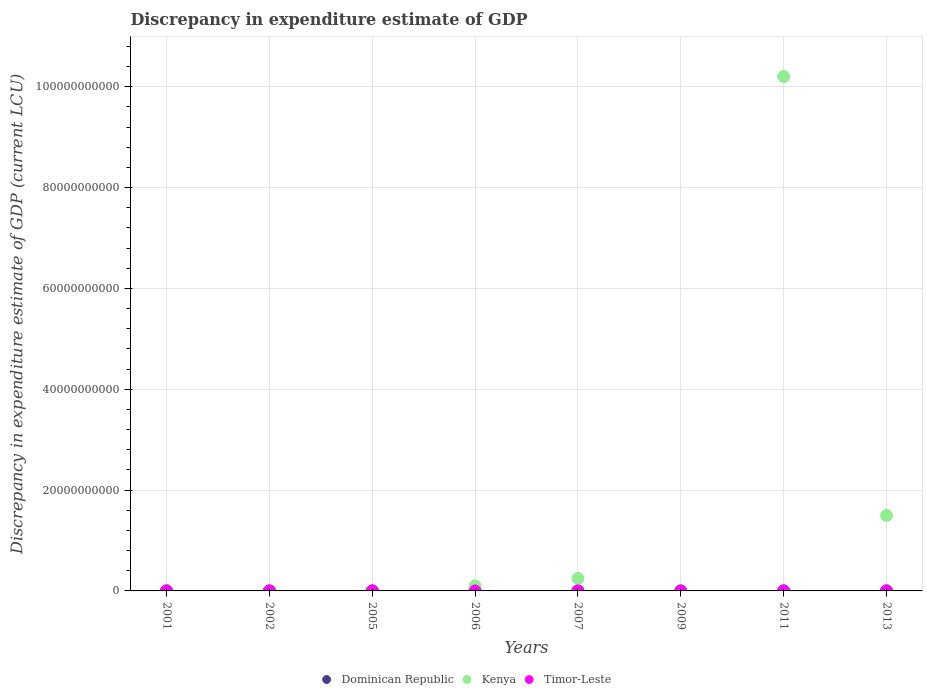How many different coloured dotlines are there?
Provide a short and direct response. 3. Is the number of dotlines equal to the number of legend labels?
Your response must be concise. No. Across all years, what is the maximum discrepancy in expenditure estimate of GDP in Kenya?
Offer a very short reply. 1.02e+11. Across all years, what is the minimum discrepancy in expenditure estimate of GDP in Timor-Leste?
Provide a succinct answer. 0. In which year was the discrepancy in expenditure estimate of GDP in Dominican Republic maximum?
Your answer should be compact. 2001. What is the total discrepancy in expenditure estimate of GDP in Timor-Leste in the graph?
Provide a succinct answer. 2.50e+06. What is the difference between the discrepancy in expenditure estimate of GDP in Dominican Republic in 2005 and that in 2007?
Provide a succinct answer. -100.12. What is the average discrepancy in expenditure estimate of GDP in Dominican Republic per year?
Your answer should be compact. 1.25e+04. In the year 2006, what is the difference between the discrepancy in expenditure estimate of GDP in Kenya and discrepancy in expenditure estimate of GDP in Dominican Republic?
Your answer should be very brief. 1.01e+09. What is the ratio of the discrepancy in expenditure estimate of GDP in Kenya in 2007 to that in 2013?
Give a very brief answer. 0.17. What is the difference between the highest and the second highest discrepancy in expenditure estimate of GDP in Dominican Republic?
Your answer should be compact. 9.99e+04. What is the difference between the highest and the lowest discrepancy in expenditure estimate of GDP in Kenya?
Your answer should be very brief. 1.02e+11. In how many years, is the discrepancy in expenditure estimate of GDP in Dominican Republic greater than the average discrepancy in expenditure estimate of GDP in Dominican Republic taken over all years?
Your answer should be compact. 1. Is the sum of the discrepancy in expenditure estimate of GDP in Dominican Republic in 2001 and 2005 greater than the maximum discrepancy in expenditure estimate of GDP in Timor-Leste across all years?
Keep it short and to the point. No. Is it the case that in every year, the sum of the discrepancy in expenditure estimate of GDP in Dominican Republic and discrepancy in expenditure estimate of GDP in Kenya  is greater than the discrepancy in expenditure estimate of GDP in Timor-Leste?
Ensure brevity in your answer.  No. Is the discrepancy in expenditure estimate of GDP in Kenya strictly less than the discrepancy in expenditure estimate of GDP in Timor-Leste over the years?
Make the answer very short. No. Are the values on the major ticks of Y-axis written in scientific E-notation?
Keep it short and to the point. No. Does the graph contain any zero values?
Make the answer very short. Yes. Does the graph contain grids?
Provide a short and direct response. Yes. How many legend labels are there?
Your response must be concise. 3. How are the legend labels stacked?
Your response must be concise. Horizontal. What is the title of the graph?
Provide a short and direct response. Discrepancy in expenditure estimate of GDP. Does "Slovak Republic" appear as one of the legend labels in the graph?
Offer a terse response. No. What is the label or title of the X-axis?
Your answer should be very brief. Years. What is the label or title of the Y-axis?
Offer a very short reply. Discrepancy in expenditure estimate of GDP (current LCU). What is the Discrepancy in expenditure estimate of GDP (current LCU) in Dominican Republic in 2001?
Make the answer very short. 1.00e+05. What is the Discrepancy in expenditure estimate of GDP (current LCU) of Timor-Leste in 2001?
Keep it short and to the point. 1.00e+06. What is the Discrepancy in expenditure estimate of GDP (current LCU) in Dominican Republic in 2002?
Ensure brevity in your answer.  0. What is the Discrepancy in expenditure estimate of GDP (current LCU) of Kenya in 2002?
Your answer should be very brief. 0. What is the Discrepancy in expenditure estimate of GDP (current LCU) of Timor-Leste in 2002?
Your answer should be very brief. 0. What is the Discrepancy in expenditure estimate of GDP (current LCU) in Dominican Republic in 2005?
Keep it short and to the point. 8e-6. What is the Discrepancy in expenditure estimate of GDP (current LCU) in Dominican Republic in 2006?
Ensure brevity in your answer.  0. What is the Discrepancy in expenditure estimate of GDP (current LCU) in Kenya in 2006?
Make the answer very short. 1.01e+09. What is the Discrepancy in expenditure estimate of GDP (current LCU) of Timor-Leste in 2006?
Your response must be concise. 1.34e-7. What is the Discrepancy in expenditure estimate of GDP (current LCU) of Dominican Republic in 2007?
Your response must be concise. 100.12. What is the Discrepancy in expenditure estimate of GDP (current LCU) in Kenya in 2007?
Your answer should be compact. 2.49e+09. What is the Discrepancy in expenditure estimate of GDP (current LCU) of Timor-Leste in 2007?
Provide a short and direct response. 1.00e+06. What is the Discrepancy in expenditure estimate of GDP (current LCU) of Dominican Republic in 2009?
Ensure brevity in your answer.  0. What is the Discrepancy in expenditure estimate of GDP (current LCU) of Dominican Republic in 2011?
Give a very brief answer. 92.59. What is the Discrepancy in expenditure estimate of GDP (current LCU) in Kenya in 2011?
Keep it short and to the point. 1.02e+11. What is the Discrepancy in expenditure estimate of GDP (current LCU) of Kenya in 2013?
Give a very brief answer. 1.50e+1. Across all years, what is the maximum Discrepancy in expenditure estimate of GDP (current LCU) in Dominican Republic?
Offer a terse response. 1.00e+05. Across all years, what is the maximum Discrepancy in expenditure estimate of GDP (current LCU) in Kenya?
Offer a terse response. 1.02e+11. Across all years, what is the maximum Discrepancy in expenditure estimate of GDP (current LCU) in Timor-Leste?
Offer a very short reply. 1.00e+06. What is the total Discrepancy in expenditure estimate of GDP (current LCU) of Dominican Republic in the graph?
Offer a very short reply. 1.00e+05. What is the total Discrepancy in expenditure estimate of GDP (current LCU) of Kenya in the graph?
Keep it short and to the point. 1.20e+11. What is the total Discrepancy in expenditure estimate of GDP (current LCU) of Timor-Leste in the graph?
Your answer should be very brief. 2.50e+06. What is the difference between the Discrepancy in expenditure estimate of GDP (current LCU) of Dominican Republic in 2001 and that in 2005?
Ensure brevity in your answer.  1.00e+05. What is the difference between the Discrepancy in expenditure estimate of GDP (current LCU) of Dominican Republic in 2001 and that in 2006?
Offer a terse response. 1.00e+05. What is the difference between the Discrepancy in expenditure estimate of GDP (current LCU) in Dominican Republic in 2001 and that in 2007?
Ensure brevity in your answer.  9.99e+04. What is the difference between the Discrepancy in expenditure estimate of GDP (current LCU) of Dominican Republic in 2001 and that in 2011?
Offer a terse response. 9.99e+04. What is the difference between the Discrepancy in expenditure estimate of GDP (current LCU) of Dominican Republic in 2005 and that in 2006?
Offer a very short reply. -0. What is the difference between the Discrepancy in expenditure estimate of GDP (current LCU) of Timor-Leste in 2005 and that in 2006?
Give a very brief answer. 5.00e+05. What is the difference between the Discrepancy in expenditure estimate of GDP (current LCU) of Dominican Republic in 2005 and that in 2007?
Your answer should be compact. -100.12. What is the difference between the Discrepancy in expenditure estimate of GDP (current LCU) of Timor-Leste in 2005 and that in 2007?
Your answer should be compact. -5.00e+05. What is the difference between the Discrepancy in expenditure estimate of GDP (current LCU) in Dominican Republic in 2005 and that in 2011?
Your answer should be compact. -92.59. What is the difference between the Discrepancy in expenditure estimate of GDP (current LCU) in Dominican Republic in 2006 and that in 2007?
Ensure brevity in your answer.  -100.12. What is the difference between the Discrepancy in expenditure estimate of GDP (current LCU) of Kenya in 2006 and that in 2007?
Provide a short and direct response. -1.48e+09. What is the difference between the Discrepancy in expenditure estimate of GDP (current LCU) of Dominican Republic in 2006 and that in 2011?
Ensure brevity in your answer.  -92.59. What is the difference between the Discrepancy in expenditure estimate of GDP (current LCU) of Kenya in 2006 and that in 2011?
Ensure brevity in your answer.  -1.01e+11. What is the difference between the Discrepancy in expenditure estimate of GDP (current LCU) in Kenya in 2006 and that in 2013?
Offer a very short reply. -1.40e+1. What is the difference between the Discrepancy in expenditure estimate of GDP (current LCU) in Dominican Republic in 2007 and that in 2011?
Ensure brevity in your answer.  7.53. What is the difference between the Discrepancy in expenditure estimate of GDP (current LCU) in Kenya in 2007 and that in 2011?
Provide a succinct answer. -9.95e+1. What is the difference between the Discrepancy in expenditure estimate of GDP (current LCU) of Kenya in 2007 and that in 2013?
Your answer should be compact. -1.25e+1. What is the difference between the Discrepancy in expenditure estimate of GDP (current LCU) in Kenya in 2011 and that in 2013?
Give a very brief answer. 8.71e+1. What is the difference between the Discrepancy in expenditure estimate of GDP (current LCU) in Dominican Republic in 2001 and the Discrepancy in expenditure estimate of GDP (current LCU) in Timor-Leste in 2005?
Your answer should be very brief. -4.00e+05. What is the difference between the Discrepancy in expenditure estimate of GDP (current LCU) of Dominican Republic in 2001 and the Discrepancy in expenditure estimate of GDP (current LCU) of Kenya in 2006?
Provide a succinct answer. -1.01e+09. What is the difference between the Discrepancy in expenditure estimate of GDP (current LCU) of Dominican Republic in 2001 and the Discrepancy in expenditure estimate of GDP (current LCU) of Kenya in 2007?
Ensure brevity in your answer.  -2.49e+09. What is the difference between the Discrepancy in expenditure estimate of GDP (current LCU) in Dominican Republic in 2001 and the Discrepancy in expenditure estimate of GDP (current LCU) in Timor-Leste in 2007?
Your answer should be very brief. -9.00e+05. What is the difference between the Discrepancy in expenditure estimate of GDP (current LCU) in Dominican Republic in 2001 and the Discrepancy in expenditure estimate of GDP (current LCU) in Kenya in 2011?
Make the answer very short. -1.02e+11. What is the difference between the Discrepancy in expenditure estimate of GDP (current LCU) in Dominican Republic in 2001 and the Discrepancy in expenditure estimate of GDP (current LCU) in Kenya in 2013?
Offer a very short reply. -1.50e+1. What is the difference between the Discrepancy in expenditure estimate of GDP (current LCU) of Dominican Republic in 2005 and the Discrepancy in expenditure estimate of GDP (current LCU) of Kenya in 2006?
Keep it short and to the point. -1.01e+09. What is the difference between the Discrepancy in expenditure estimate of GDP (current LCU) of Dominican Republic in 2005 and the Discrepancy in expenditure estimate of GDP (current LCU) of Kenya in 2007?
Provide a short and direct response. -2.49e+09. What is the difference between the Discrepancy in expenditure estimate of GDP (current LCU) of Dominican Republic in 2005 and the Discrepancy in expenditure estimate of GDP (current LCU) of Kenya in 2011?
Make the answer very short. -1.02e+11. What is the difference between the Discrepancy in expenditure estimate of GDP (current LCU) of Dominican Republic in 2005 and the Discrepancy in expenditure estimate of GDP (current LCU) of Kenya in 2013?
Provide a succinct answer. -1.50e+1. What is the difference between the Discrepancy in expenditure estimate of GDP (current LCU) in Dominican Republic in 2006 and the Discrepancy in expenditure estimate of GDP (current LCU) in Kenya in 2007?
Your response must be concise. -2.49e+09. What is the difference between the Discrepancy in expenditure estimate of GDP (current LCU) of Dominican Republic in 2006 and the Discrepancy in expenditure estimate of GDP (current LCU) of Timor-Leste in 2007?
Your response must be concise. -1.00e+06. What is the difference between the Discrepancy in expenditure estimate of GDP (current LCU) of Kenya in 2006 and the Discrepancy in expenditure estimate of GDP (current LCU) of Timor-Leste in 2007?
Your answer should be very brief. 1.01e+09. What is the difference between the Discrepancy in expenditure estimate of GDP (current LCU) in Dominican Republic in 2006 and the Discrepancy in expenditure estimate of GDP (current LCU) in Kenya in 2011?
Offer a terse response. -1.02e+11. What is the difference between the Discrepancy in expenditure estimate of GDP (current LCU) in Dominican Republic in 2006 and the Discrepancy in expenditure estimate of GDP (current LCU) in Kenya in 2013?
Offer a very short reply. -1.50e+1. What is the difference between the Discrepancy in expenditure estimate of GDP (current LCU) of Dominican Republic in 2007 and the Discrepancy in expenditure estimate of GDP (current LCU) of Kenya in 2011?
Offer a very short reply. -1.02e+11. What is the difference between the Discrepancy in expenditure estimate of GDP (current LCU) in Dominican Republic in 2007 and the Discrepancy in expenditure estimate of GDP (current LCU) in Kenya in 2013?
Your answer should be compact. -1.50e+1. What is the difference between the Discrepancy in expenditure estimate of GDP (current LCU) of Dominican Republic in 2011 and the Discrepancy in expenditure estimate of GDP (current LCU) of Kenya in 2013?
Give a very brief answer. -1.50e+1. What is the average Discrepancy in expenditure estimate of GDP (current LCU) in Dominican Republic per year?
Keep it short and to the point. 1.25e+04. What is the average Discrepancy in expenditure estimate of GDP (current LCU) in Kenya per year?
Keep it short and to the point. 1.51e+1. What is the average Discrepancy in expenditure estimate of GDP (current LCU) of Timor-Leste per year?
Keep it short and to the point. 3.12e+05. In the year 2001, what is the difference between the Discrepancy in expenditure estimate of GDP (current LCU) of Dominican Republic and Discrepancy in expenditure estimate of GDP (current LCU) of Timor-Leste?
Provide a short and direct response. -9.00e+05. In the year 2005, what is the difference between the Discrepancy in expenditure estimate of GDP (current LCU) of Dominican Republic and Discrepancy in expenditure estimate of GDP (current LCU) of Timor-Leste?
Your response must be concise. -5.00e+05. In the year 2006, what is the difference between the Discrepancy in expenditure estimate of GDP (current LCU) in Dominican Republic and Discrepancy in expenditure estimate of GDP (current LCU) in Kenya?
Your response must be concise. -1.01e+09. In the year 2006, what is the difference between the Discrepancy in expenditure estimate of GDP (current LCU) in Dominican Republic and Discrepancy in expenditure estimate of GDP (current LCU) in Timor-Leste?
Provide a short and direct response. 0. In the year 2006, what is the difference between the Discrepancy in expenditure estimate of GDP (current LCU) of Kenya and Discrepancy in expenditure estimate of GDP (current LCU) of Timor-Leste?
Keep it short and to the point. 1.01e+09. In the year 2007, what is the difference between the Discrepancy in expenditure estimate of GDP (current LCU) in Dominican Republic and Discrepancy in expenditure estimate of GDP (current LCU) in Kenya?
Offer a very short reply. -2.49e+09. In the year 2007, what is the difference between the Discrepancy in expenditure estimate of GDP (current LCU) of Dominican Republic and Discrepancy in expenditure estimate of GDP (current LCU) of Timor-Leste?
Ensure brevity in your answer.  -1.00e+06. In the year 2007, what is the difference between the Discrepancy in expenditure estimate of GDP (current LCU) of Kenya and Discrepancy in expenditure estimate of GDP (current LCU) of Timor-Leste?
Your response must be concise. 2.49e+09. In the year 2011, what is the difference between the Discrepancy in expenditure estimate of GDP (current LCU) of Dominican Republic and Discrepancy in expenditure estimate of GDP (current LCU) of Kenya?
Your answer should be very brief. -1.02e+11. What is the ratio of the Discrepancy in expenditure estimate of GDP (current LCU) of Dominican Republic in 2001 to that in 2005?
Offer a very short reply. 1.25e+1. What is the ratio of the Discrepancy in expenditure estimate of GDP (current LCU) in Timor-Leste in 2001 to that in 2005?
Your response must be concise. 2. What is the ratio of the Discrepancy in expenditure estimate of GDP (current LCU) of Dominican Republic in 2001 to that in 2006?
Ensure brevity in your answer.  8.33e+08. What is the ratio of the Discrepancy in expenditure estimate of GDP (current LCU) in Timor-Leste in 2001 to that in 2006?
Keep it short and to the point. 7.46e+12. What is the ratio of the Discrepancy in expenditure estimate of GDP (current LCU) in Dominican Republic in 2001 to that in 2007?
Make the answer very short. 998.8. What is the ratio of the Discrepancy in expenditure estimate of GDP (current LCU) in Dominican Republic in 2001 to that in 2011?
Your answer should be compact. 1080.03. What is the ratio of the Discrepancy in expenditure estimate of GDP (current LCU) of Dominican Republic in 2005 to that in 2006?
Offer a very short reply. 0.07. What is the ratio of the Discrepancy in expenditure estimate of GDP (current LCU) of Timor-Leste in 2005 to that in 2006?
Give a very brief answer. 3.73e+12. What is the ratio of the Discrepancy in expenditure estimate of GDP (current LCU) of Dominican Republic in 2005 to that in 2007?
Give a very brief answer. 0. What is the ratio of the Discrepancy in expenditure estimate of GDP (current LCU) of Timor-Leste in 2005 to that in 2007?
Your answer should be compact. 0.5. What is the ratio of the Discrepancy in expenditure estimate of GDP (current LCU) in Kenya in 2006 to that in 2007?
Ensure brevity in your answer.  0.41. What is the ratio of the Discrepancy in expenditure estimate of GDP (current LCU) of Timor-Leste in 2006 to that in 2007?
Keep it short and to the point. 0. What is the ratio of the Discrepancy in expenditure estimate of GDP (current LCU) in Dominican Republic in 2006 to that in 2011?
Provide a succinct answer. 0. What is the ratio of the Discrepancy in expenditure estimate of GDP (current LCU) in Kenya in 2006 to that in 2011?
Provide a succinct answer. 0.01. What is the ratio of the Discrepancy in expenditure estimate of GDP (current LCU) of Kenya in 2006 to that in 2013?
Your answer should be very brief. 0.07. What is the ratio of the Discrepancy in expenditure estimate of GDP (current LCU) of Dominican Republic in 2007 to that in 2011?
Your response must be concise. 1.08. What is the ratio of the Discrepancy in expenditure estimate of GDP (current LCU) in Kenya in 2007 to that in 2011?
Make the answer very short. 0.02. What is the ratio of the Discrepancy in expenditure estimate of GDP (current LCU) of Kenya in 2007 to that in 2013?
Offer a terse response. 0.17. What is the ratio of the Discrepancy in expenditure estimate of GDP (current LCU) in Kenya in 2011 to that in 2013?
Offer a very short reply. 6.82. What is the difference between the highest and the second highest Discrepancy in expenditure estimate of GDP (current LCU) in Dominican Republic?
Offer a very short reply. 9.99e+04. What is the difference between the highest and the second highest Discrepancy in expenditure estimate of GDP (current LCU) of Kenya?
Make the answer very short. 8.71e+1. What is the difference between the highest and the second highest Discrepancy in expenditure estimate of GDP (current LCU) in Timor-Leste?
Give a very brief answer. 0. What is the difference between the highest and the lowest Discrepancy in expenditure estimate of GDP (current LCU) in Dominican Republic?
Offer a very short reply. 1.00e+05. What is the difference between the highest and the lowest Discrepancy in expenditure estimate of GDP (current LCU) in Kenya?
Offer a terse response. 1.02e+11. What is the difference between the highest and the lowest Discrepancy in expenditure estimate of GDP (current LCU) in Timor-Leste?
Your answer should be compact. 1.00e+06. 